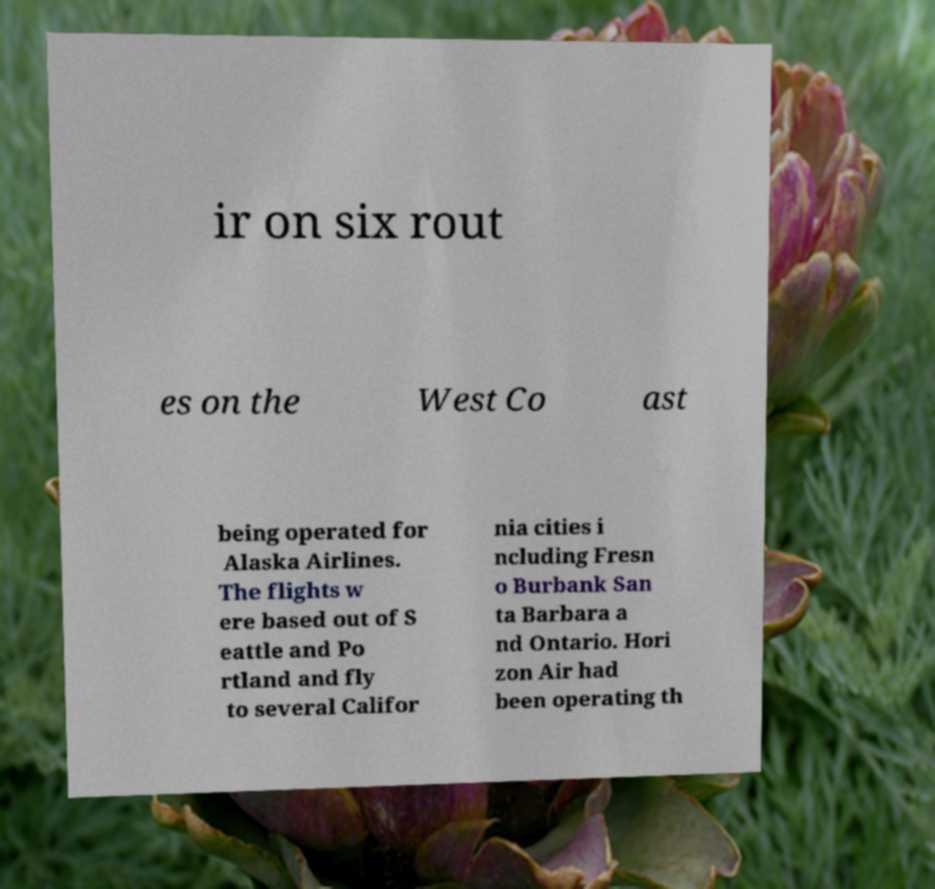There's text embedded in this image that I need extracted. Can you transcribe it verbatim? ir on six rout es on the West Co ast being operated for Alaska Airlines. The flights w ere based out of S eattle and Po rtland and fly to several Califor nia cities i ncluding Fresn o Burbank San ta Barbara a nd Ontario. Hori zon Air had been operating th 